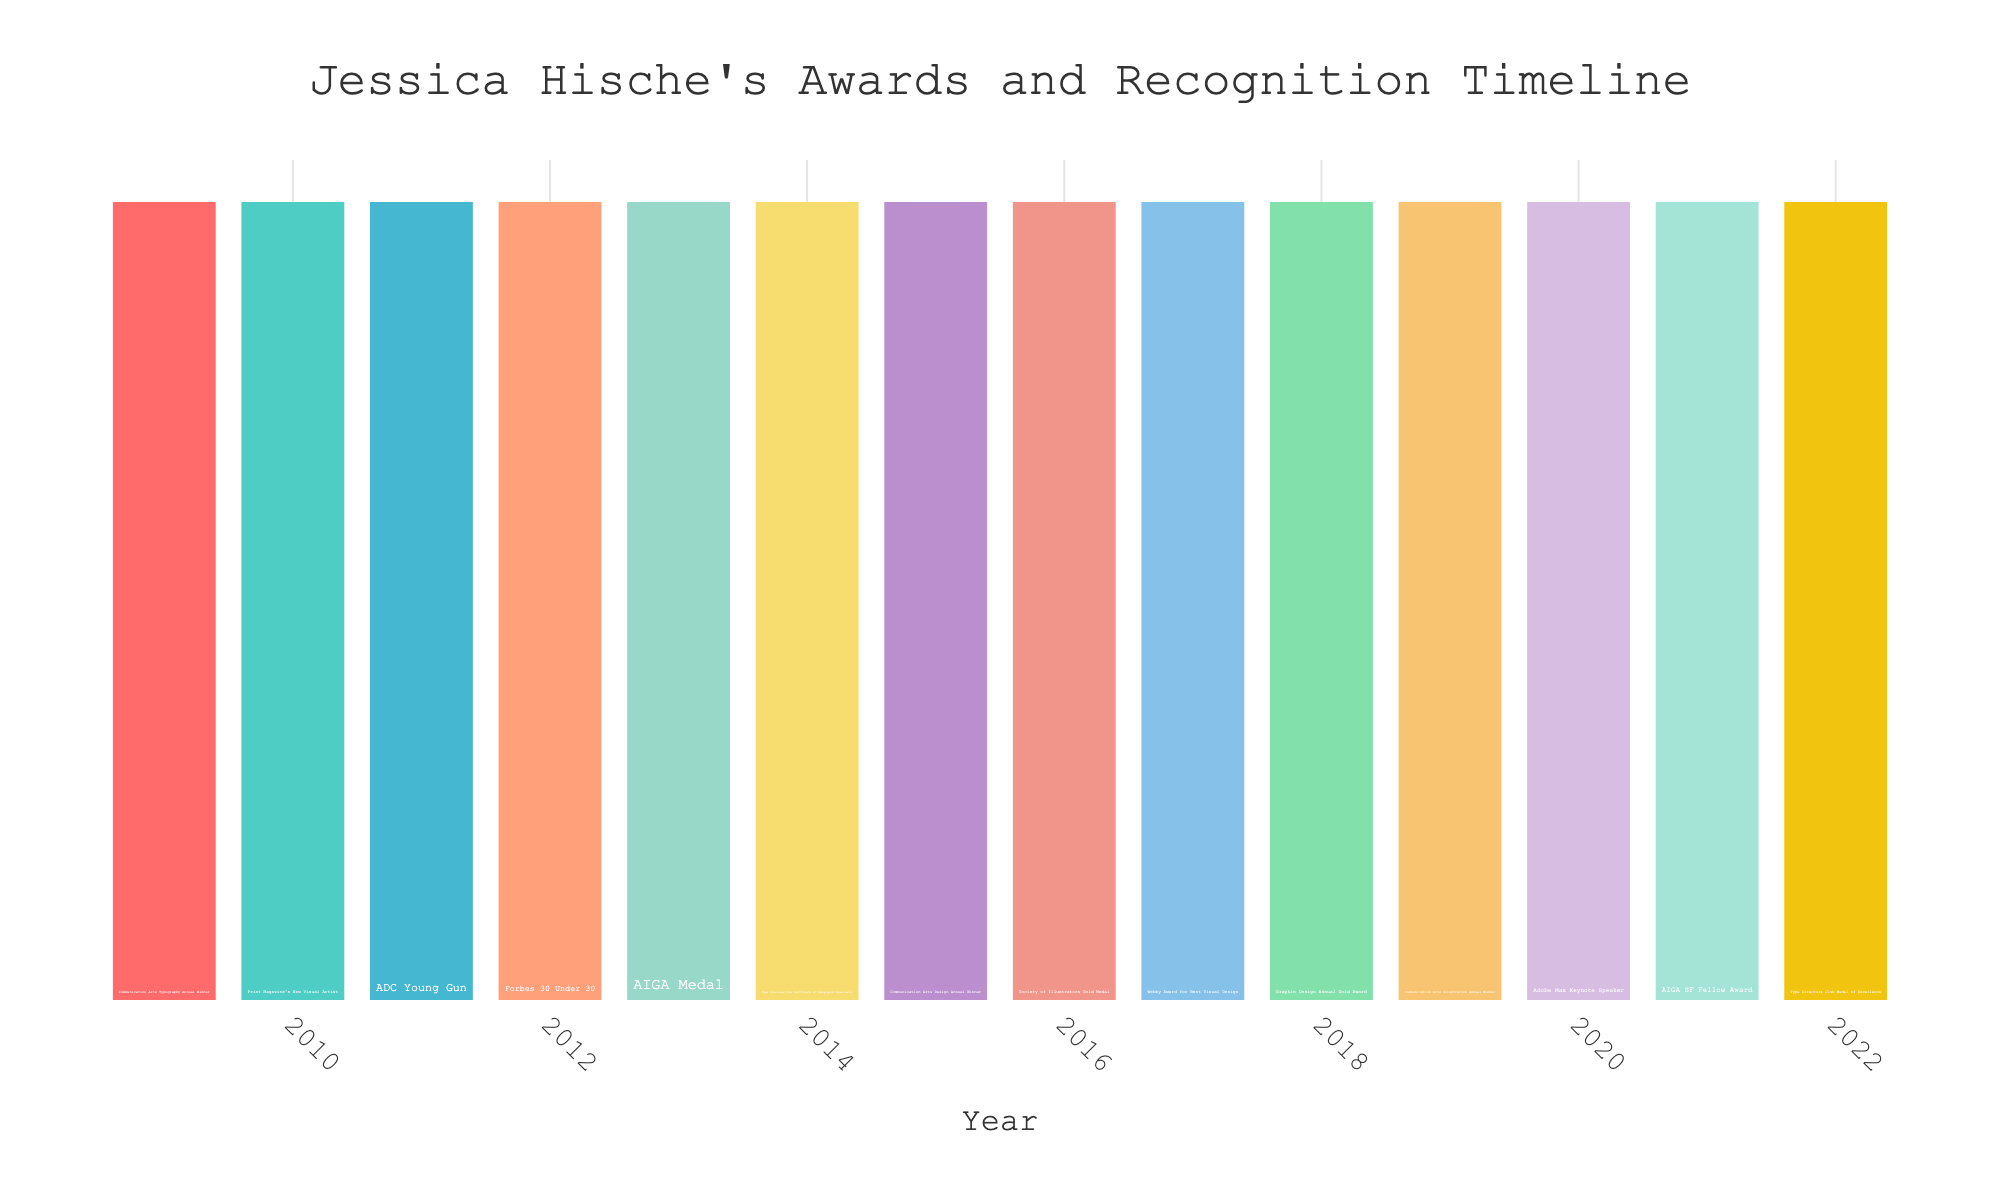How many years did Jessica Hische receive awards and recognition consecutively from 2009 to 2012? We need to count the consecutive years from 2009 to 2012 based on the figure. These years are 2009, 2010, 2011, and 2012. So, the number of consecutive years is 4.
Answer: 4 Which award was received by Jessica Hische in 2015, and was it related to Communication Arts? To answer this, we look at the year 2015 in the figure and check the award listed. The award is "Communication Arts Design Annual Winner".
Answer: Communication Arts Design Annual Winner Between the years 2009 and 2020, which year did Jessica Hische not receive any awards? We need to examine each year between 2009 and 2020 in the figure. All years between 2009 and 2020 are marked with awards, meaning no year in this range is missing an award.
Answer: None Which year had more prestigious recognition: 2012 or 2017? For this, we compare the awards listed for 2012 and 2017. In 2012, Jessica was listed in "Forbes 30 Under 30", and in 2017, she received the "Webby Award for Best Visual Design". Both are significant, but broadly, the "Forbes 30 Under 30" could be considered more prestigious.
Answer: 2012 How many times was Jessica Hische recognized by the Type Directors Club? We scan through the figure to find all mentions of the Type Directors Club. The years are 2014 and 2022, so she was recognized twice.
Answer: 2 Identify the year with the longest-awarded recognition description among 2011 and 2016. First, we check the length of the award names for 2011 ("ADC Young Gun") and 2016 ("Society of Illustrators Gold Medal"). The award in 2016 has a longer description.
Answer: 2016 What is the total count of awards for the years divisible by 3 from 2009 to 2019? First, identify the years divisible by 3: 2009, 2012, 2015, and 2018. Sum up the awards for these years: 2009 (1), 2012 (1), 2015 (1), and 2018 (1). The total is 1+1+1+1=4.
Answer: 4 Which award is listed for the year 2020? Locate the year 2020 on the figure and check the corresponding award. It's "Adobe Max Keynote Speaker".
Answer: Adobe Max Keynote Speaker 